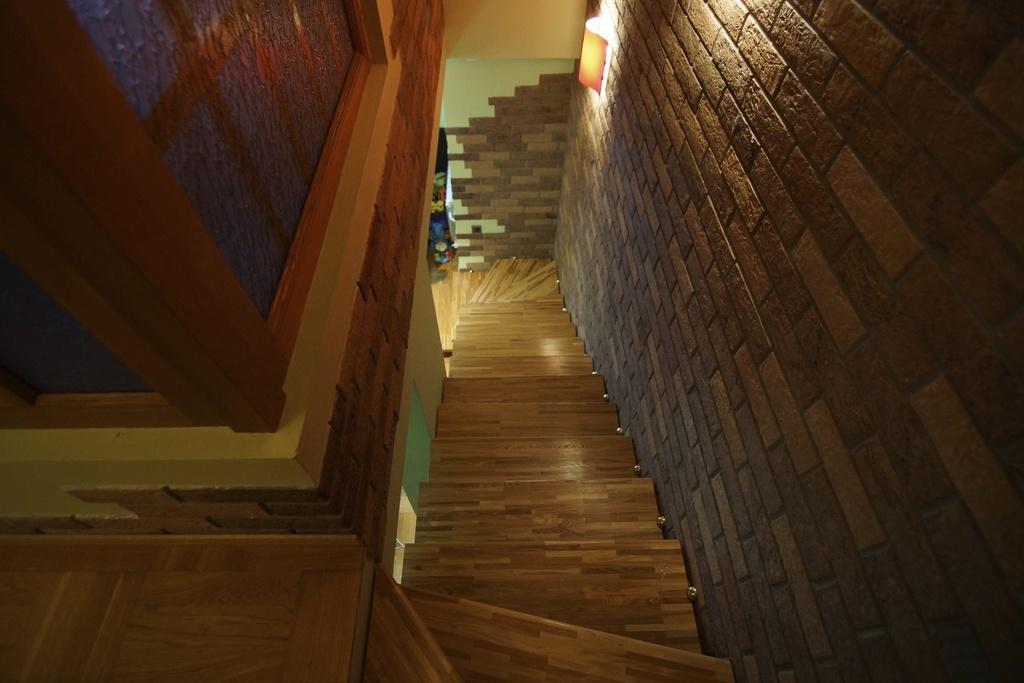Describe this image in one or two sentences. in this image we can see the inner view of a building and we can see the staircase in the middle of the image and we can see the light attached to the wall. 